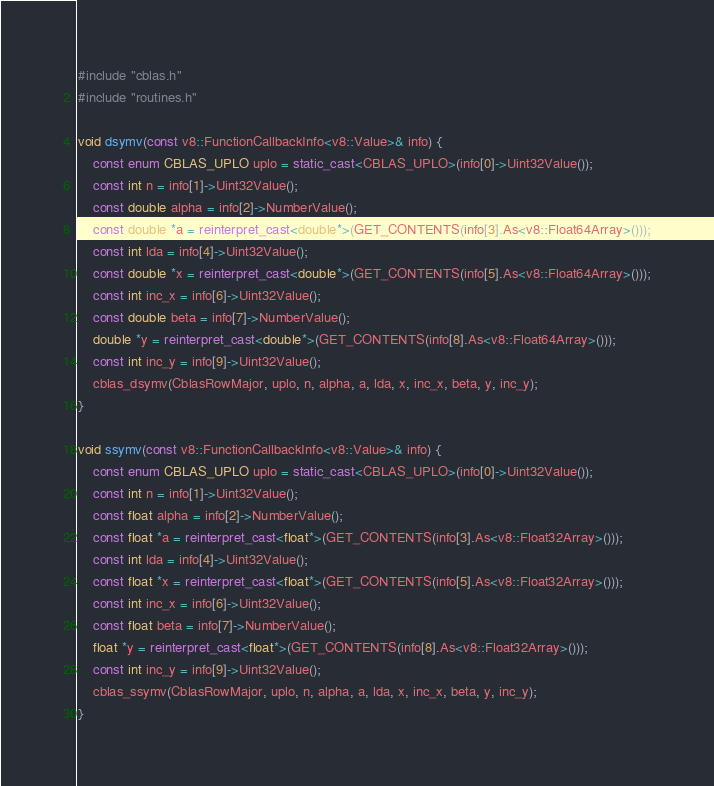Convert code to text. <code><loc_0><loc_0><loc_500><loc_500><_C++_>#include "cblas.h"
#include "routines.h"

void dsymv(const v8::FunctionCallbackInfo<v8::Value>& info) {
	const enum CBLAS_UPLO uplo = static_cast<CBLAS_UPLO>(info[0]->Uint32Value());
	const int n = info[1]->Uint32Value();
	const double alpha = info[2]->NumberValue();
	const double *a = reinterpret_cast<double*>(GET_CONTENTS(info[3].As<v8::Float64Array>()));
	const int lda = info[4]->Uint32Value();
	const double *x = reinterpret_cast<double*>(GET_CONTENTS(info[5].As<v8::Float64Array>()));
	const int inc_x = info[6]->Uint32Value();
	const double beta = info[7]->NumberValue();
	double *y = reinterpret_cast<double*>(GET_CONTENTS(info[8].As<v8::Float64Array>()));
	const int inc_y = info[9]->Uint32Value();
	cblas_dsymv(CblasRowMajor, uplo, n, alpha, a, lda, x, inc_x, beta, y, inc_y);
}

void ssymv(const v8::FunctionCallbackInfo<v8::Value>& info) {
	const enum CBLAS_UPLO uplo = static_cast<CBLAS_UPLO>(info[0]->Uint32Value());
	const int n = info[1]->Uint32Value();
	const float alpha = info[2]->NumberValue();
	const float *a = reinterpret_cast<float*>(GET_CONTENTS(info[3].As<v8::Float32Array>()));
	const int lda = info[4]->Uint32Value();
	const float *x = reinterpret_cast<float*>(GET_CONTENTS(info[5].As<v8::Float32Array>()));
	const int inc_x = info[6]->Uint32Value();
	const float beta = info[7]->NumberValue();
	float *y = reinterpret_cast<float*>(GET_CONTENTS(info[8].As<v8::Float32Array>()));
	const int inc_y = info[9]->Uint32Value();
	cblas_ssymv(CblasRowMajor, uplo, n, alpha, a, lda, x, inc_x, beta, y, inc_y);
}
</code> 